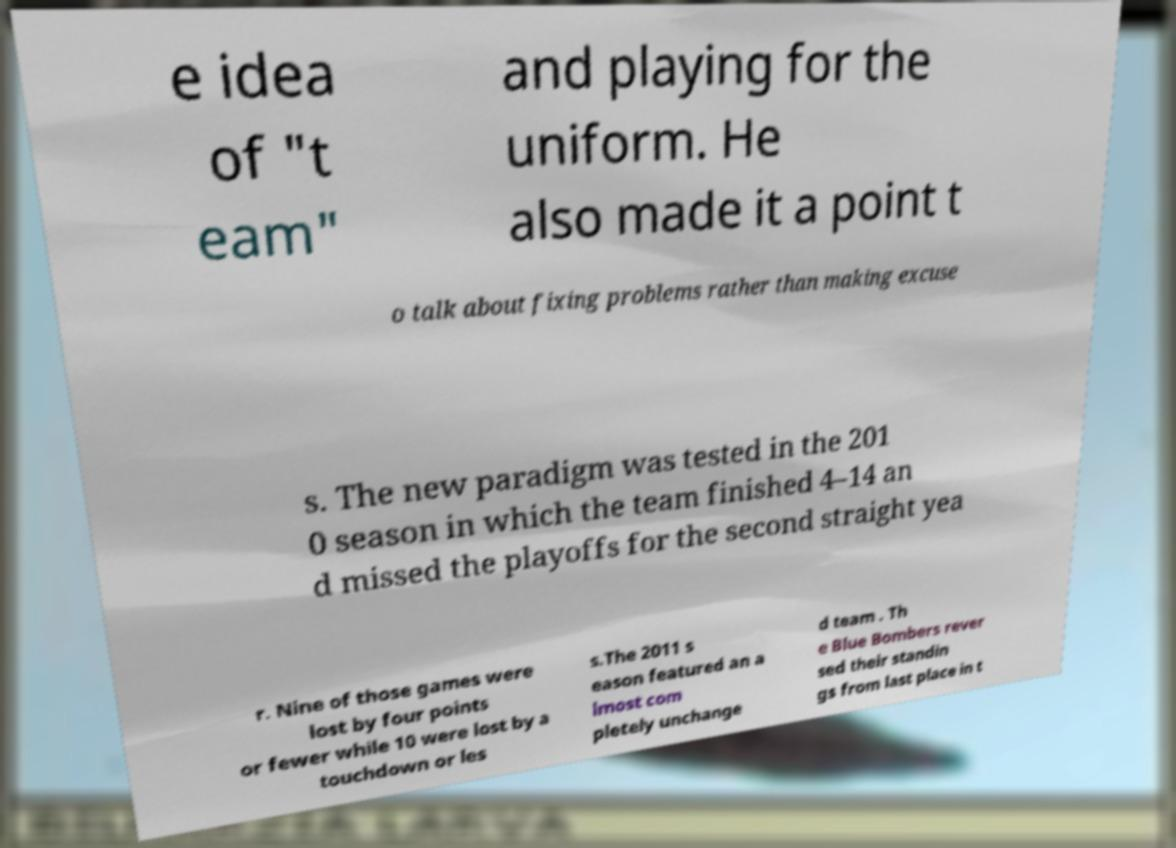For documentation purposes, I need the text within this image transcribed. Could you provide that? e idea of "t eam" and playing for the uniform. He also made it a point t o talk about fixing problems rather than making excuse s. The new paradigm was tested in the 201 0 season in which the team finished 4–14 an d missed the playoffs for the second straight yea r. Nine of those games were lost by four points or fewer while 10 were lost by a touchdown or les s.The 2011 s eason featured an a lmost com pletely unchange d team . Th e Blue Bombers rever sed their standin gs from last place in t 